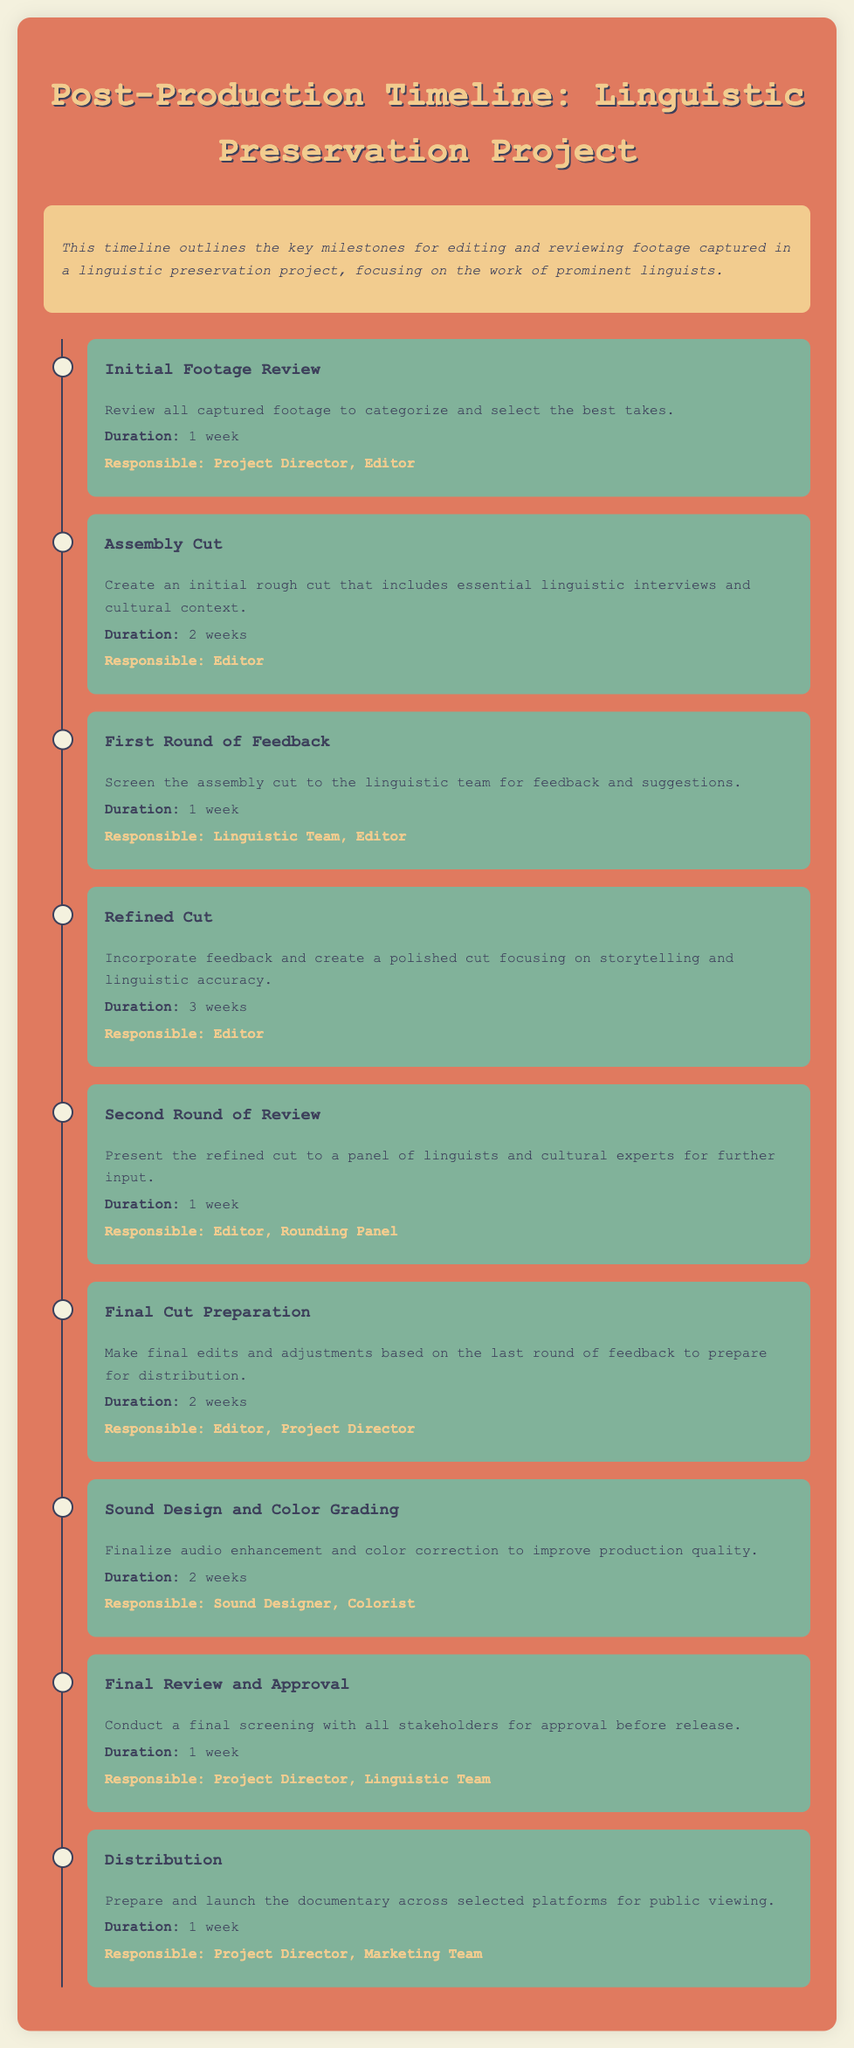What is the duration of the Initial Footage Review? The duration for the Initial Footage Review is specified in the document as 1 week.
Answer: 1 week Who is responsible for the Assembly Cut? The document indicates that the Editor is responsible for creating the Assembly Cut.
Answer: Editor What milestone follows the First Round of Feedback? The milestone that follows the First Round of Feedback is the Refined Cut, as per the timeline.
Answer: Refined Cut How many weeks are allocated for the Sound Design and Color Grading? The timeline states that the Sound Design and Color Grading process is allocated 2 weeks.
Answer: 2 weeks What is the purpose of the Final Review and Approval? The document states that the purpose of the Final Review and Approval is to conduct a final screening with all stakeholders for their approval.
Answer: Approval Which team is responsible for distribution? The document mentions that the Marketing Team, along with the Project Director, is responsible for distribution.
Answer: Marketing Team What major task occurs during the Refined Cut milestone? The Refined Cut milestone focuses on incorporating feedback and creating a polished cut.
Answer: Polished cut How many milestones are there in total? The total number of milestones mentioned in the document is eight, indicating the steps in the post-production timeline.
Answer: Eight 